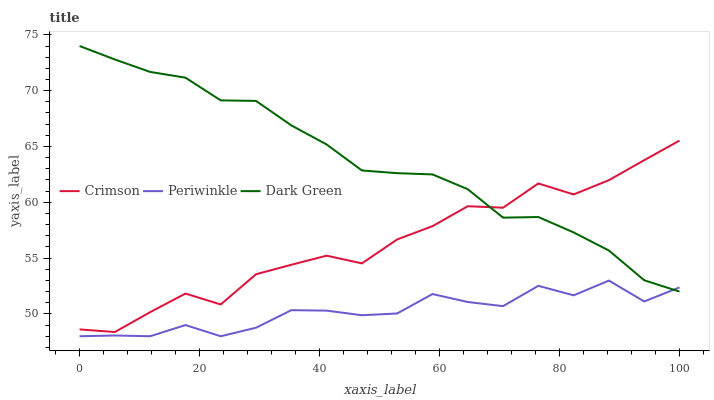Does Periwinkle have the minimum area under the curve?
Answer yes or no. Yes. Does Dark Green have the maximum area under the curve?
Answer yes or no. Yes. Does Dark Green have the minimum area under the curve?
Answer yes or no. No. Does Periwinkle have the maximum area under the curve?
Answer yes or no. No. Is Dark Green the smoothest?
Answer yes or no. Yes. Is Crimson the roughest?
Answer yes or no. Yes. Is Periwinkle the smoothest?
Answer yes or no. No. Is Periwinkle the roughest?
Answer yes or no. No. Does Periwinkle have the lowest value?
Answer yes or no. Yes. Does Dark Green have the lowest value?
Answer yes or no. No. Does Dark Green have the highest value?
Answer yes or no. Yes. Does Periwinkle have the highest value?
Answer yes or no. No. Is Periwinkle less than Crimson?
Answer yes or no. Yes. Is Crimson greater than Periwinkle?
Answer yes or no. Yes. Does Dark Green intersect Periwinkle?
Answer yes or no. Yes. Is Dark Green less than Periwinkle?
Answer yes or no. No. Is Dark Green greater than Periwinkle?
Answer yes or no. No. Does Periwinkle intersect Crimson?
Answer yes or no. No. 